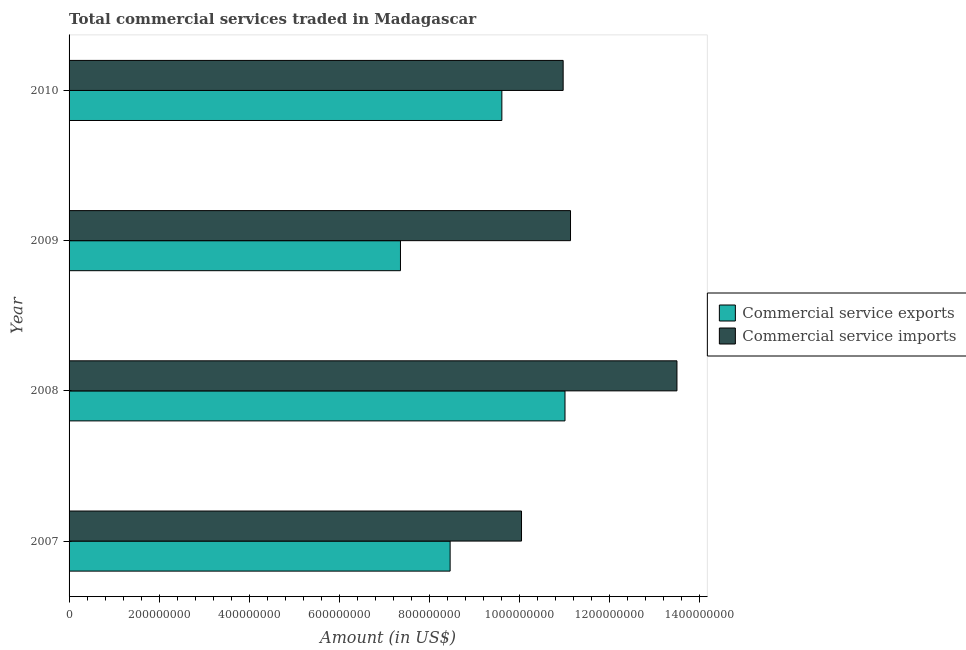How many groups of bars are there?
Provide a succinct answer. 4. Are the number of bars on each tick of the Y-axis equal?
Your answer should be very brief. Yes. How many bars are there on the 1st tick from the bottom?
Your answer should be very brief. 2. What is the label of the 2nd group of bars from the top?
Your response must be concise. 2009. What is the amount of commercial service imports in 2007?
Ensure brevity in your answer.  1.00e+09. Across all years, what is the maximum amount of commercial service exports?
Your answer should be compact. 1.10e+09. Across all years, what is the minimum amount of commercial service exports?
Ensure brevity in your answer.  7.36e+08. In which year was the amount of commercial service exports maximum?
Provide a short and direct response. 2008. What is the total amount of commercial service exports in the graph?
Offer a terse response. 3.65e+09. What is the difference between the amount of commercial service imports in 2009 and that in 2010?
Offer a terse response. 1.64e+07. What is the difference between the amount of commercial service imports in 2009 and the amount of commercial service exports in 2010?
Make the answer very short. 1.53e+08. What is the average amount of commercial service exports per year?
Give a very brief answer. 9.11e+08. In the year 2009, what is the difference between the amount of commercial service imports and amount of commercial service exports?
Provide a short and direct response. 3.78e+08. What is the ratio of the amount of commercial service imports in 2008 to that in 2010?
Your answer should be compact. 1.23. What is the difference between the highest and the second highest amount of commercial service exports?
Provide a succinct answer. 1.40e+08. What is the difference between the highest and the lowest amount of commercial service exports?
Your response must be concise. 3.65e+08. In how many years, is the amount of commercial service imports greater than the average amount of commercial service imports taken over all years?
Ensure brevity in your answer.  1. What does the 1st bar from the top in 2007 represents?
Keep it short and to the point. Commercial service imports. What does the 1st bar from the bottom in 2007 represents?
Keep it short and to the point. Commercial service exports. How many bars are there?
Provide a short and direct response. 8. How many years are there in the graph?
Your answer should be compact. 4. What is the difference between two consecutive major ticks on the X-axis?
Your response must be concise. 2.00e+08. Are the values on the major ticks of X-axis written in scientific E-notation?
Your response must be concise. No. How are the legend labels stacked?
Your answer should be compact. Vertical. What is the title of the graph?
Provide a short and direct response. Total commercial services traded in Madagascar. What is the label or title of the X-axis?
Offer a very short reply. Amount (in US$). What is the label or title of the Y-axis?
Ensure brevity in your answer.  Year. What is the Amount (in US$) of Commercial service exports in 2007?
Your answer should be very brief. 8.46e+08. What is the Amount (in US$) in Commercial service imports in 2007?
Provide a short and direct response. 1.00e+09. What is the Amount (in US$) in Commercial service exports in 2008?
Offer a terse response. 1.10e+09. What is the Amount (in US$) in Commercial service imports in 2008?
Offer a terse response. 1.35e+09. What is the Amount (in US$) of Commercial service exports in 2009?
Your response must be concise. 7.36e+08. What is the Amount (in US$) of Commercial service imports in 2009?
Give a very brief answer. 1.11e+09. What is the Amount (in US$) of Commercial service exports in 2010?
Ensure brevity in your answer.  9.61e+08. What is the Amount (in US$) in Commercial service imports in 2010?
Your answer should be very brief. 1.10e+09. Across all years, what is the maximum Amount (in US$) in Commercial service exports?
Provide a succinct answer. 1.10e+09. Across all years, what is the maximum Amount (in US$) in Commercial service imports?
Your answer should be compact. 1.35e+09. Across all years, what is the minimum Amount (in US$) in Commercial service exports?
Ensure brevity in your answer.  7.36e+08. Across all years, what is the minimum Amount (in US$) in Commercial service imports?
Offer a very short reply. 1.00e+09. What is the total Amount (in US$) in Commercial service exports in the graph?
Offer a terse response. 3.65e+09. What is the total Amount (in US$) of Commercial service imports in the graph?
Make the answer very short. 4.57e+09. What is the difference between the Amount (in US$) of Commercial service exports in 2007 and that in 2008?
Keep it short and to the point. -2.55e+08. What is the difference between the Amount (in US$) in Commercial service imports in 2007 and that in 2008?
Your answer should be compact. -3.45e+08. What is the difference between the Amount (in US$) in Commercial service exports in 2007 and that in 2009?
Provide a short and direct response. 1.10e+08. What is the difference between the Amount (in US$) of Commercial service imports in 2007 and that in 2009?
Keep it short and to the point. -1.09e+08. What is the difference between the Amount (in US$) of Commercial service exports in 2007 and that in 2010?
Provide a succinct answer. -1.15e+08. What is the difference between the Amount (in US$) in Commercial service imports in 2007 and that in 2010?
Your response must be concise. -9.25e+07. What is the difference between the Amount (in US$) in Commercial service exports in 2008 and that in 2009?
Offer a very short reply. 3.65e+08. What is the difference between the Amount (in US$) of Commercial service imports in 2008 and that in 2009?
Ensure brevity in your answer.  2.36e+08. What is the difference between the Amount (in US$) of Commercial service exports in 2008 and that in 2010?
Make the answer very short. 1.40e+08. What is the difference between the Amount (in US$) of Commercial service imports in 2008 and that in 2010?
Provide a short and direct response. 2.53e+08. What is the difference between the Amount (in US$) in Commercial service exports in 2009 and that in 2010?
Your answer should be very brief. -2.25e+08. What is the difference between the Amount (in US$) of Commercial service imports in 2009 and that in 2010?
Ensure brevity in your answer.  1.64e+07. What is the difference between the Amount (in US$) of Commercial service exports in 2007 and the Amount (in US$) of Commercial service imports in 2008?
Offer a very short reply. -5.04e+08. What is the difference between the Amount (in US$) in Commercial service exports in 2007 and the Amount (in US$) in Commercial service imports in 2009?
Your answer should be compact. -2.67e+08. What is the difference between the Amount (in US$) of Commercial service exports in 2007 and the Amount (in US$) of Commercial service imports in 2010?
Make the answer very short. -2.51e+08. What is the difference between the Amount (in US$) in Commercial service exports in 2008 and the Amount (in US$) in Commercial service imports in 2009?
Keep it short and to the point. -1.23e+07. What is the difference between the Amount (in US$) in Commercial service exports in 2008 and the Amount (in US$) in Commercial service imports in 2010?
Ensure brevity in your answer.  4.10e+06. What is the difference between the Amount (in US$) of Commercial service exports in 2009 and the Amount (in US$) of Commercial service imports in 2010?
Provide a succinct answer. -3.61e+08. What is the average Amount (in US$) in Commercial service exports per year?
Your response must be concise. 9.11e+08. What is the average Amount (in US$) in Commercial service imports per year?
Make the answer very short. 1.14e+09. In the year 2007, what is the difference between the Amount (in US$) of Commercial service exports and Amount (in US$) of Commercial service imports?
Ensure brevity in your answer.  -1.59e+08. In the year 2008, what is the difference between the Amount (in US$) in Commercial service exports and Amount (in US$) in Commercial service imports?
Offer a terse response. -2.49e+08. In the year 2009, what is the difference between the Amount (in US$) of Commercial service exports and Amount (in US$) of Commercial service imports?
Make the answer very short. -3.78e+08. In the year 2010, what is the difference between the Amount (in US$) in Commercial service exports and Amount (in US$) in Commercial service imports?
Make the answer very short. -1.36e+08. What is the ratio of the Amount (in US$) of Commercial service exports in 2007 to that in 2008?
Offer a terse response. 0.77. What is the ratio of the Amount (in US$) in Commercial service imports in 2007 to that in 2008?
Your response must be concise. 0.74. What is the ratio of the Amount (in US$) of Commercial service exports in 2007 to that in 2009?
Your response must be concise. 1.15. What is the ratio of the Amount (in US$) of Commercial service imports in 2007 to that in 2009?
Provide a short and direct response. 0.9. What is the ratio of the Amount (in US$) of Commercial service exports in 2007 to that in 2010?
Offer a very short reply. 0.88. What is the ratio of the Amount (in US$) of Commercial service imports in 2007 to that in 2010?
Provide a succinct answer. 0.92. What is the ratio of the Amount (in US$) in Commercial service exports in 2008 to that in 2009?
Ensure brevity in your answer.  1.5. What is the ratio of the Amount (in US$) in Commercial service imports in 2008 to that in 2009?
Provide a succinct answer. 1.21. What is the ratio of the Amount (in US$) of Commercial service exports in 2008 to that in 2010?
Make the answer very short. 1.15. What is the ratio of the Amount (in US$) in Commercial service imports in 2008 to that in 2010?
Your response must be concise. 1.23. What is the ratio of the Amount (in US$) in Commercial service exports in 2009 to that in 2010?
Provide a short and direct response. 0.77. What is the ratio of the Amount (in US$) of Commercial service imports in 2009 to that in 2010?
Keep it short and to the point. 1.01. What is the difference between the highest and the second highest Amount (in US$) of Commercial service exports?
Your response must be concise. 1.40e+08. What is the difference between the highest and the second highest Amount (in US$) of Commercial service imports?
Your response must be concise. 2.36e+08. What is the difference between the highest and the lowest Amount (in US$) of Commercial service exports?
Keep it short and to the point. 3.65e+08. What is the difference between the highest and the lowest Amount (in US$) of Commercial service imports?
Offer a very short reply. 3.45e+08. 